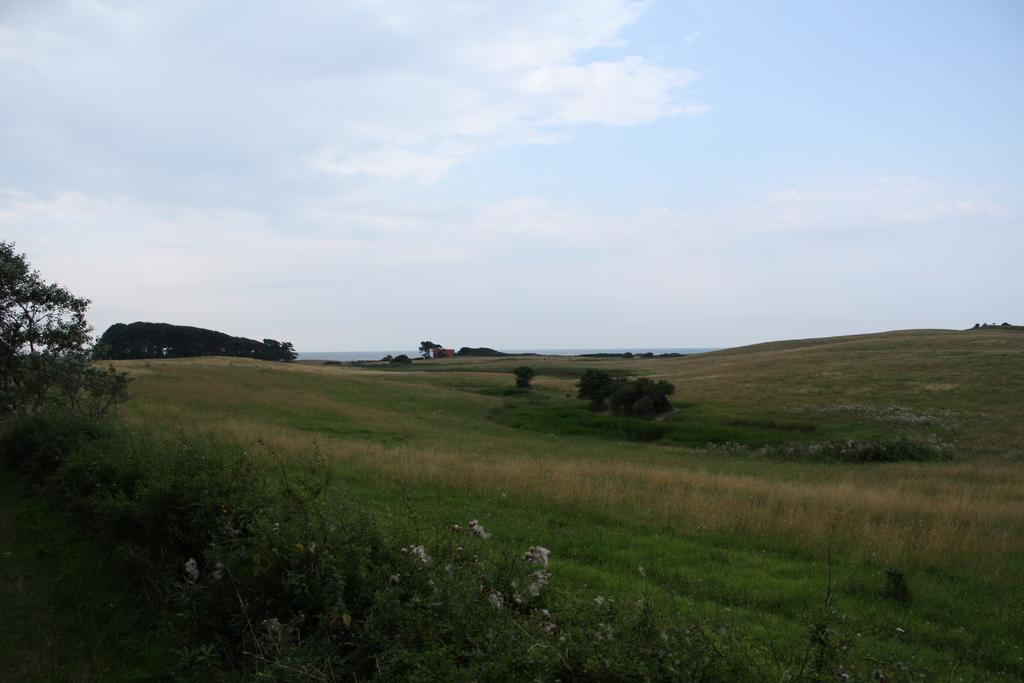What type of vegetation can be seen in the image? There is grass and plants in the image. What can be seen in the background of the image? There are trees, clouds, and the sky visible in the background of the image. What type of plant is the yak eating in the image? There is no yak present in the image, and therefore no such activity can be observed. What is the yak using to communicate with others in the image? There is no yak or mouth present in the image, so it is not possible to determine how communication might occur. 